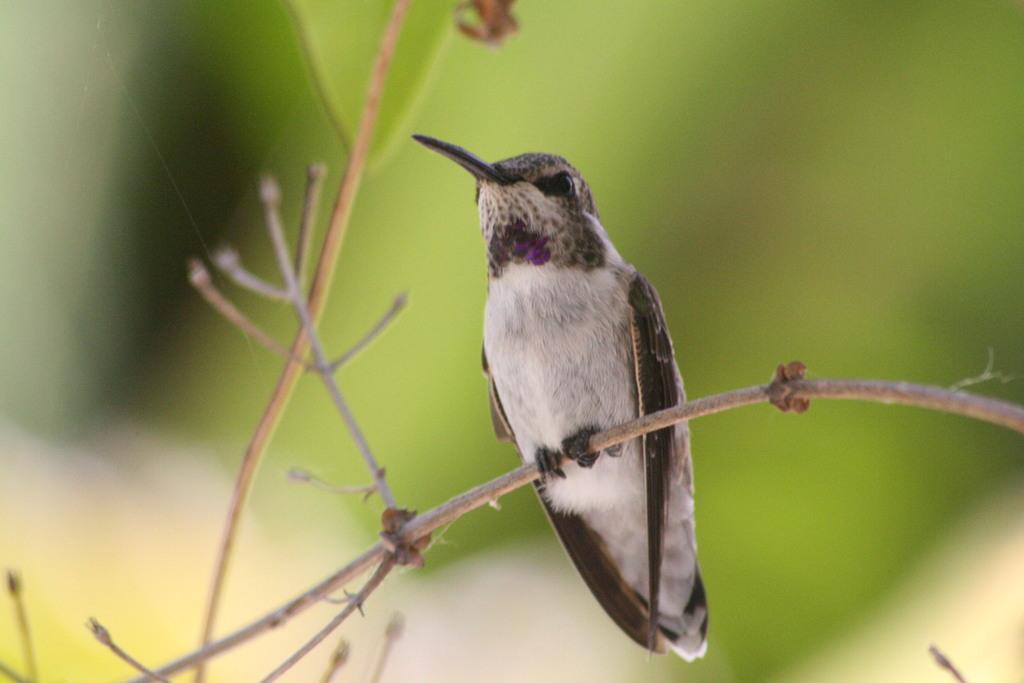Describe this image in one or two sentences. In the picture I can see a bird on the plant stem. The background of the image is blurred, which is in green color. 